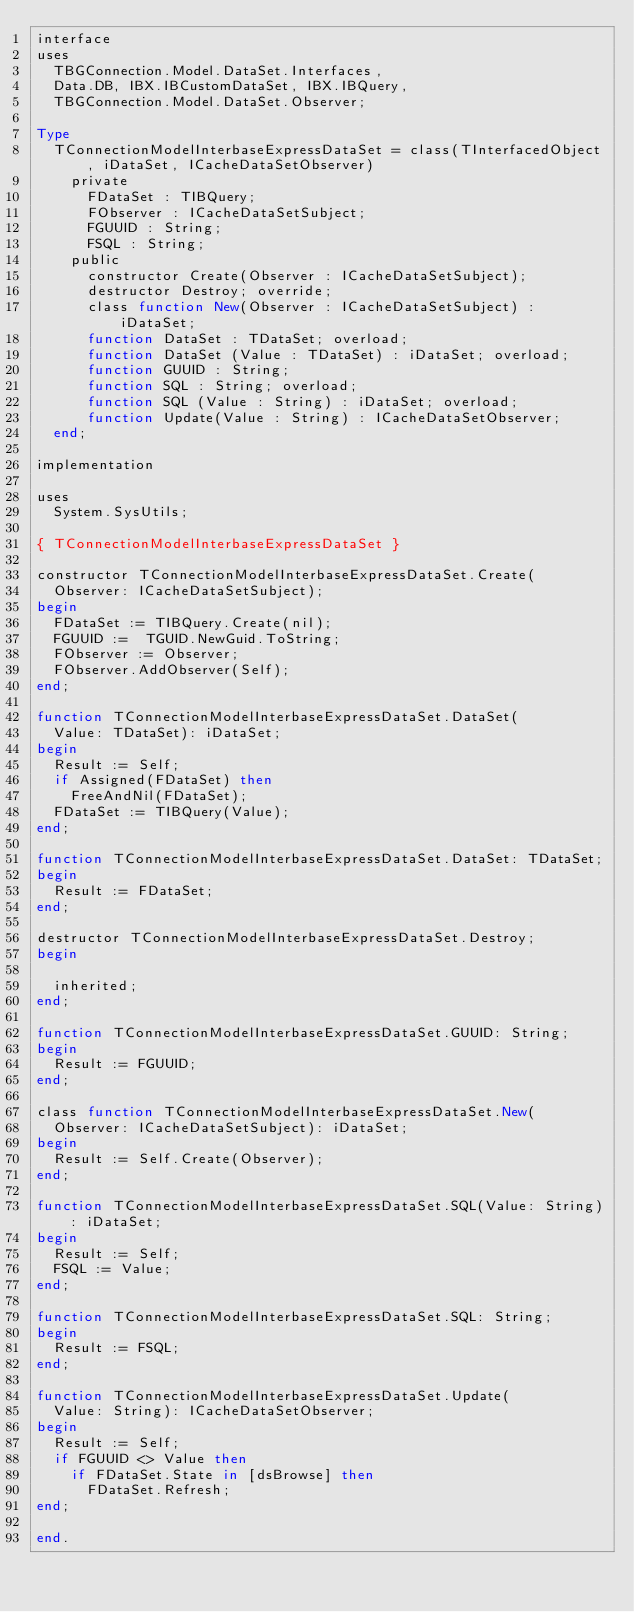<code> <loc_0><loc_0><loc_500><loc_500><_Pascal_>interface
uses
  TBGConnection.Model.DataSet.Interfaces,
  Data.DB, IBX.IBCustomDataSet, IBX.IBQuery,
  TBGConnection.Model.DataSet.Observer;

Type
  TConnectionModelInterbaseExpressDataSet = class(TInterfacedObject, iDataSet, ICacheDataSetObserver)
    private
      FDataSet : TIBQuery;
      FObserver : ICacheDataSetSubject;
      FGUUID : String;
      FSQL : String;
    public
      constructor Create(Observer : ICacheDataSetSubject);
      destructor Destroy; override;
      class function New(Observer : ICacheDataSetSubject) : iDataSet;
      function DataSet : TDataSet; overload;
      function DataSet (Value : TDataSet) : iDataSet; overload;
      function GUUID : String;
      function SQL : String; overload;
      function SQL (Value : String) : iDataSet; overload;
      function Update(Value : String) : ICacheDataSetObserver;
  end;

implementation

uses
  System.SysUtils;

{ TConnectionModelInterbaseExpressDataSet }

constructor TConnectionModelInterbaseExpressDataSet.Create(
  Observer: ICacheDataSetSubject);
begin
  FDataSet := TIBQuery.Create(nil);
  FGUUID :=  TGUID.NewGuid.ToString;
  FObserver := Observer;
  FObserver.AddObserver(Self);
end;

function TConnectionModelInterbaseExpressDataSet.DataSet(
  Value: TDataSet): iDataSet;
begin
  Result := Self;
  if Assigned(FDataSet) then
    FreeAndNil(FDataSet);
  FDataSet := TIBQuery(Value);
end;

function TConnectionModelInterbaseExpressDataSet.DataSet: TDataSet;
begin
  Result := FDataSet;
end;

destructor TConnectionModelInterbaseExpressDataSet.Destroy;
begin

  inherited;
end;

function TConnectionModelInterbaseExpressDataSet.GUUID: String;
begin
  Result := FGUUID;
end;

class function TConnectionModelInterbaseExpressDataSet.New(
  Observer: ICacheDataSetSubject): iDataSet;
begin
  Result := Self.Create(Observer);
end;

function TConnectionModelInterbaseExpressDataSet.SQL(Value: String): iDataSet;
begin
  Result := Self;
  FSQL := Value;
end;

function TConnectionModelInterbaseExpressDataSet.SQL: String;
begin
  Result := FSQL;
end;

function TConnectionModelInterbaseExpressDataSet.Update(
  Value: String): ICacheDataSetObserver;
begin
  Result := Self;
  if FGUUID <> Value then
    if FDataSet.State in [dsBrowse] then
      FDataSet.Refresh;
end;

end.
</code> 